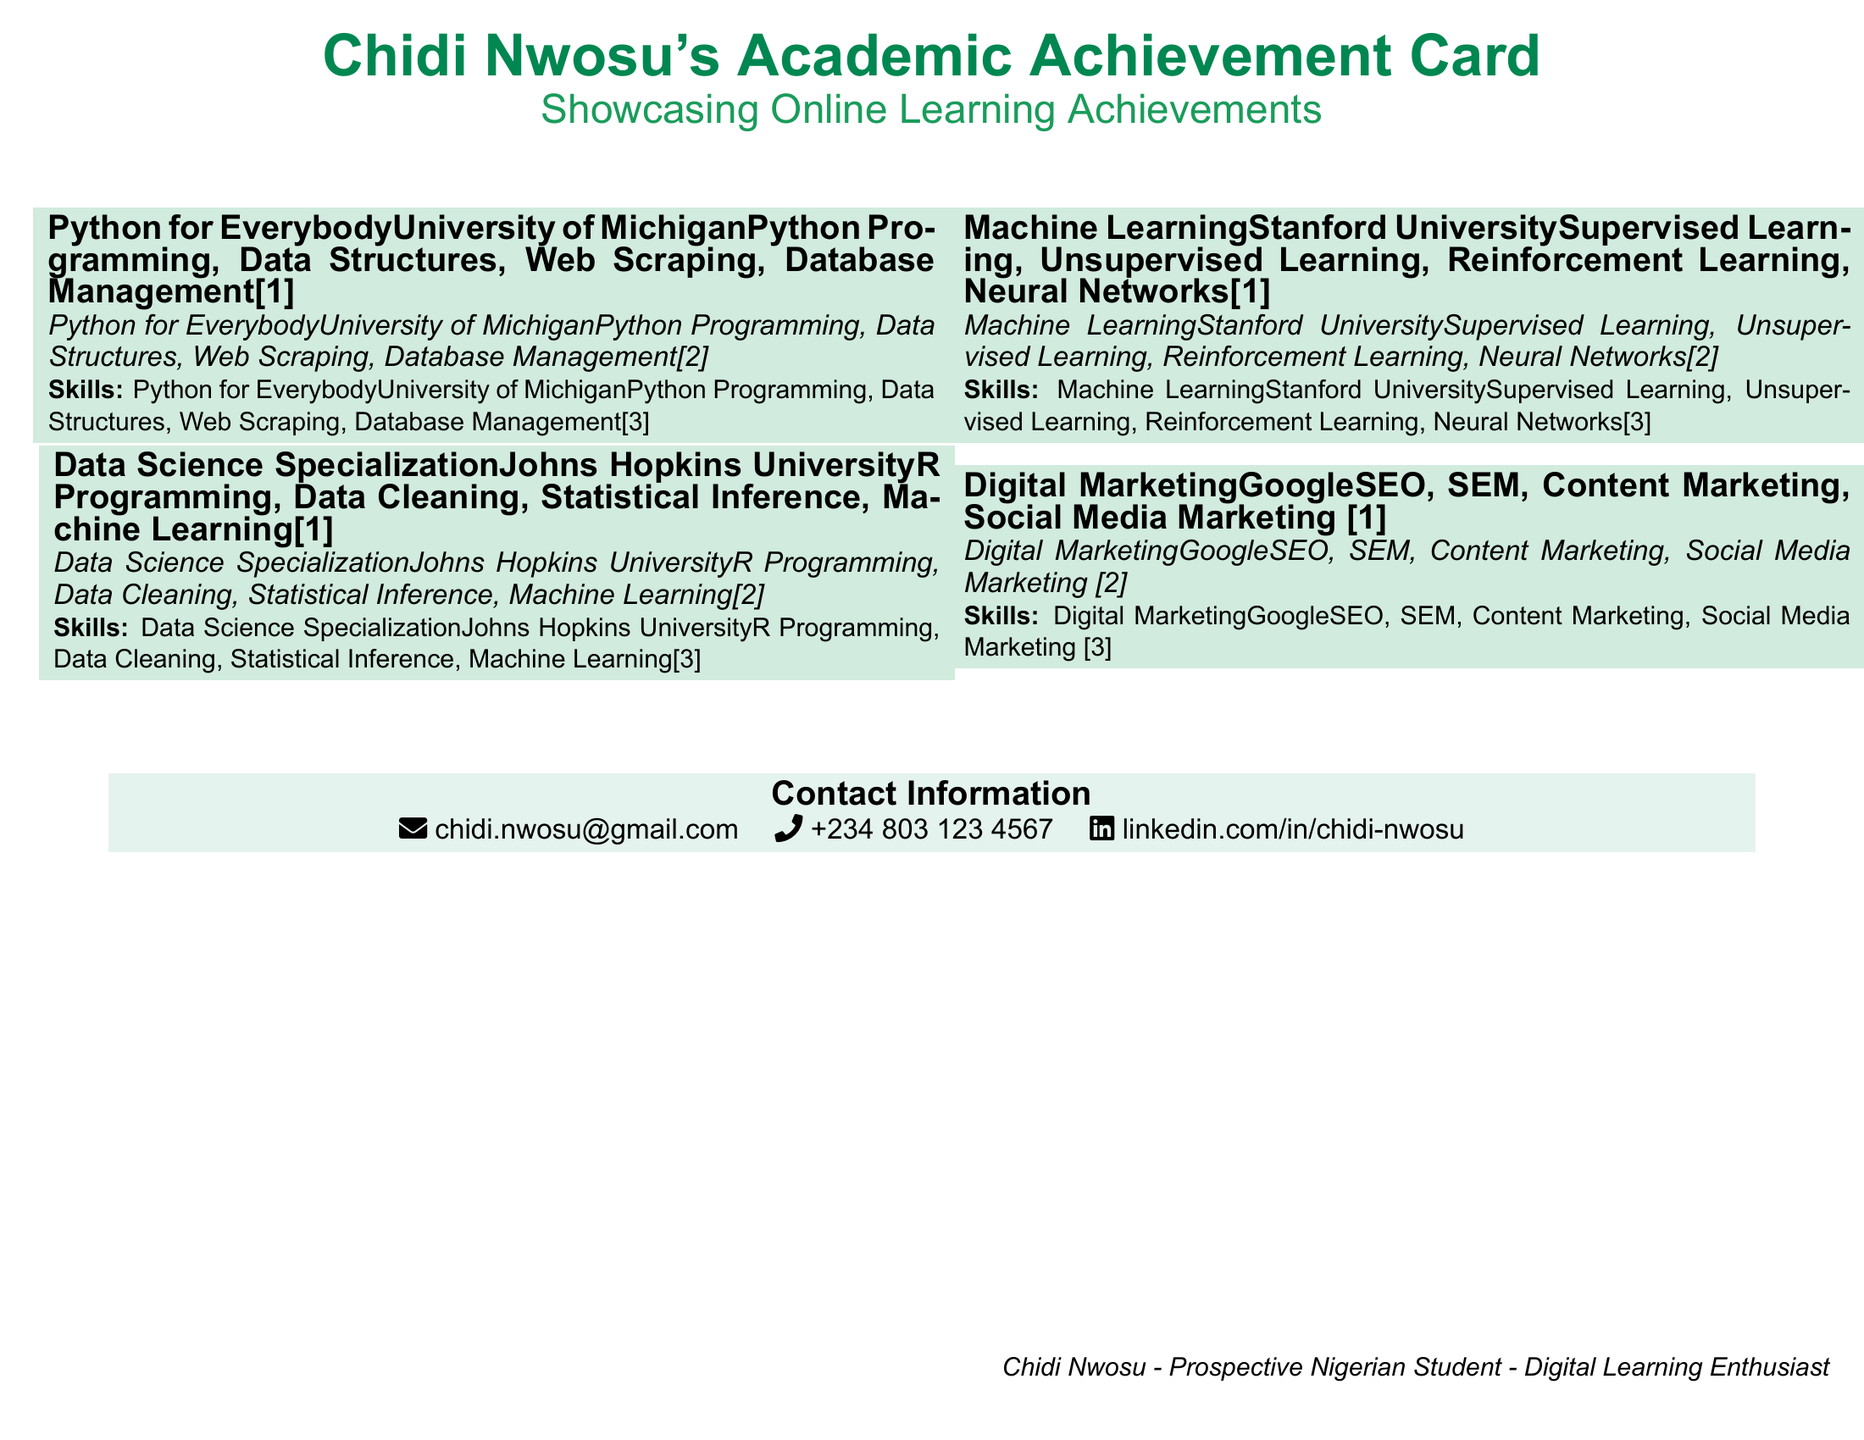What is the name on the Academic Achievement Card? The card is titled with the name "Chidi Nwosu".
Answer: Chidi Nwosu Which institution issued the certificate for "Python for Everybody"? The issuing institution for this achievement is the "University of Michigan".
Answer: University of Michigan What skill is associated with the "Data Science Specialization"? The skills mentioned for this specialization include "R Programming, Data Cleaning, Statistical Inference, Machine Learning".
Answer: R Programming, Data Cleaning, Statistical Inference, Machine Learning How many achievements are listed on the card? There are four achievements showcased on the card.
Answer: Four What is the email address provided in the contact information? The email address listed is "chidi.nwosu@gmail.com".
Answer: chidi.nwosu@gmail.com Which achievement covers skills related to digital marketing? The achievement that focuses on digital marketing is "Digital Marketing".
Answer: Digital Marketing What color is used for the card's title text? The title text is in the color "nigeriangreen".
Answer: nigeriangreen What type of learning does Chidi Nwosu identify as enthusiastic about? Chidi Nwosu is described as a "Digital Learning Enthusiast".
Answer: Digital Learning Enthusiast What is the phone number listed on the card? The card lists the phone number as "+234 803 123 4567".
Answer: +234 803 123 4567 